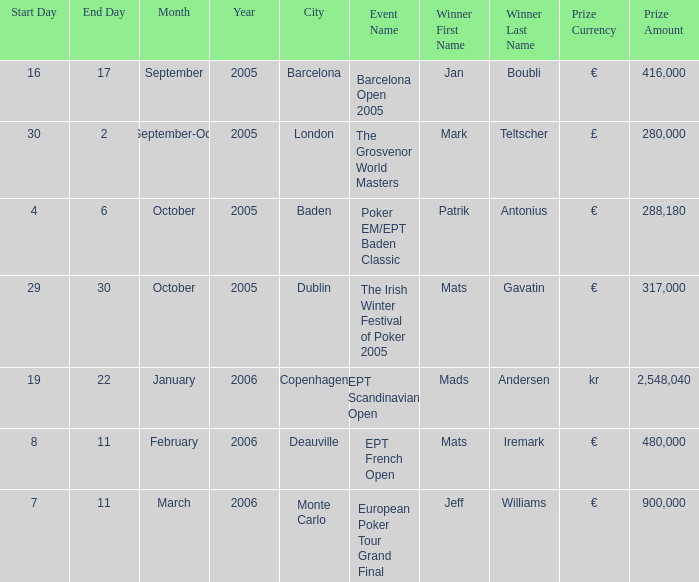Which occasion was won by mark teltscher? The Grosvenor World Masters. 